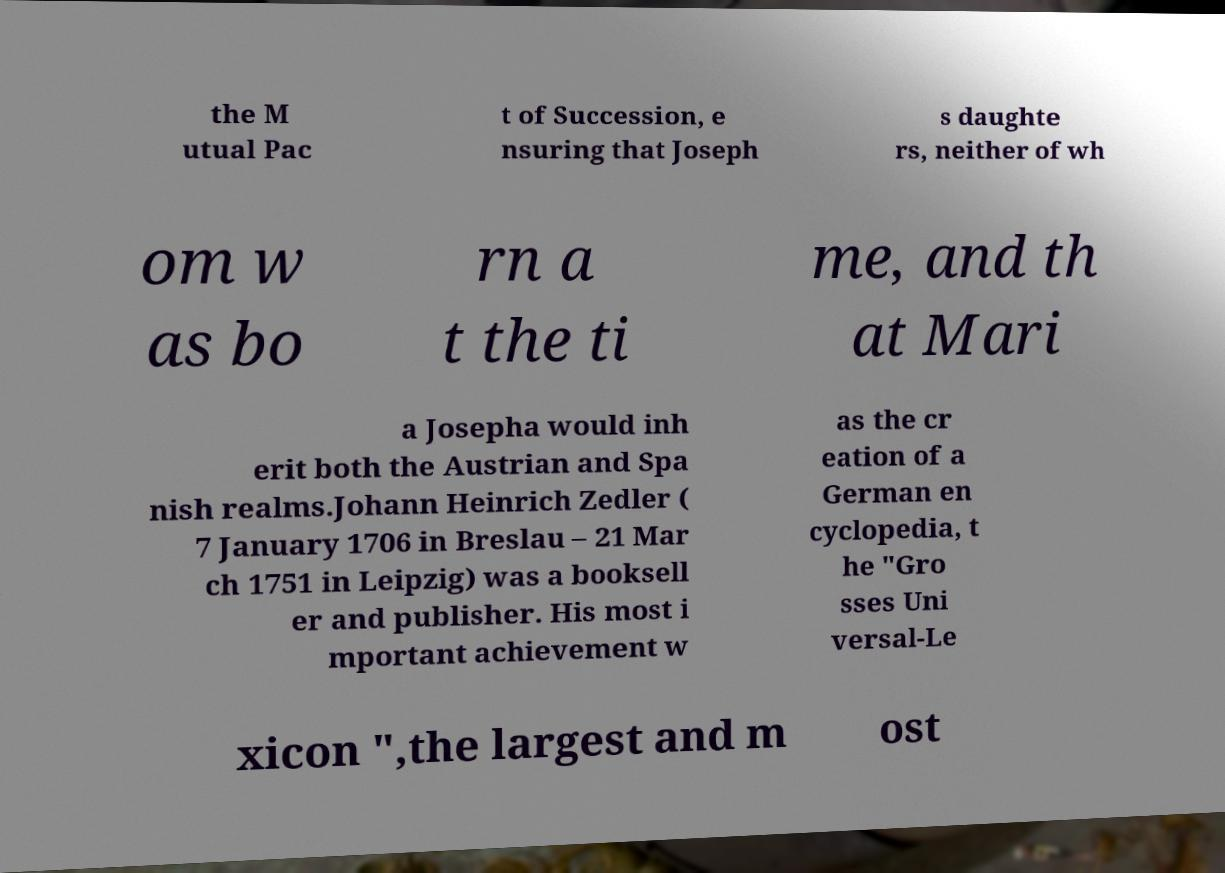Please identify and transcribe the text found in this image. the M utual Pac t of Succession, e nsuring that Joseph s daughte rs, neither of wh om w as bo rn a t the ti me, and th at Mari a Josepha would inh erit both the Austrian and Spa nish realms.Johann Heinrich Zedler ( 7 January 1706 in Breslau – 21 Mar ch 1751 in Leipzig) was a booksell er and publisher. His most i mportant achievement w as the cr eation of a German en cyclopedia, t he "Gro sses Uni versal-Le xicon ",the largest and m ost 